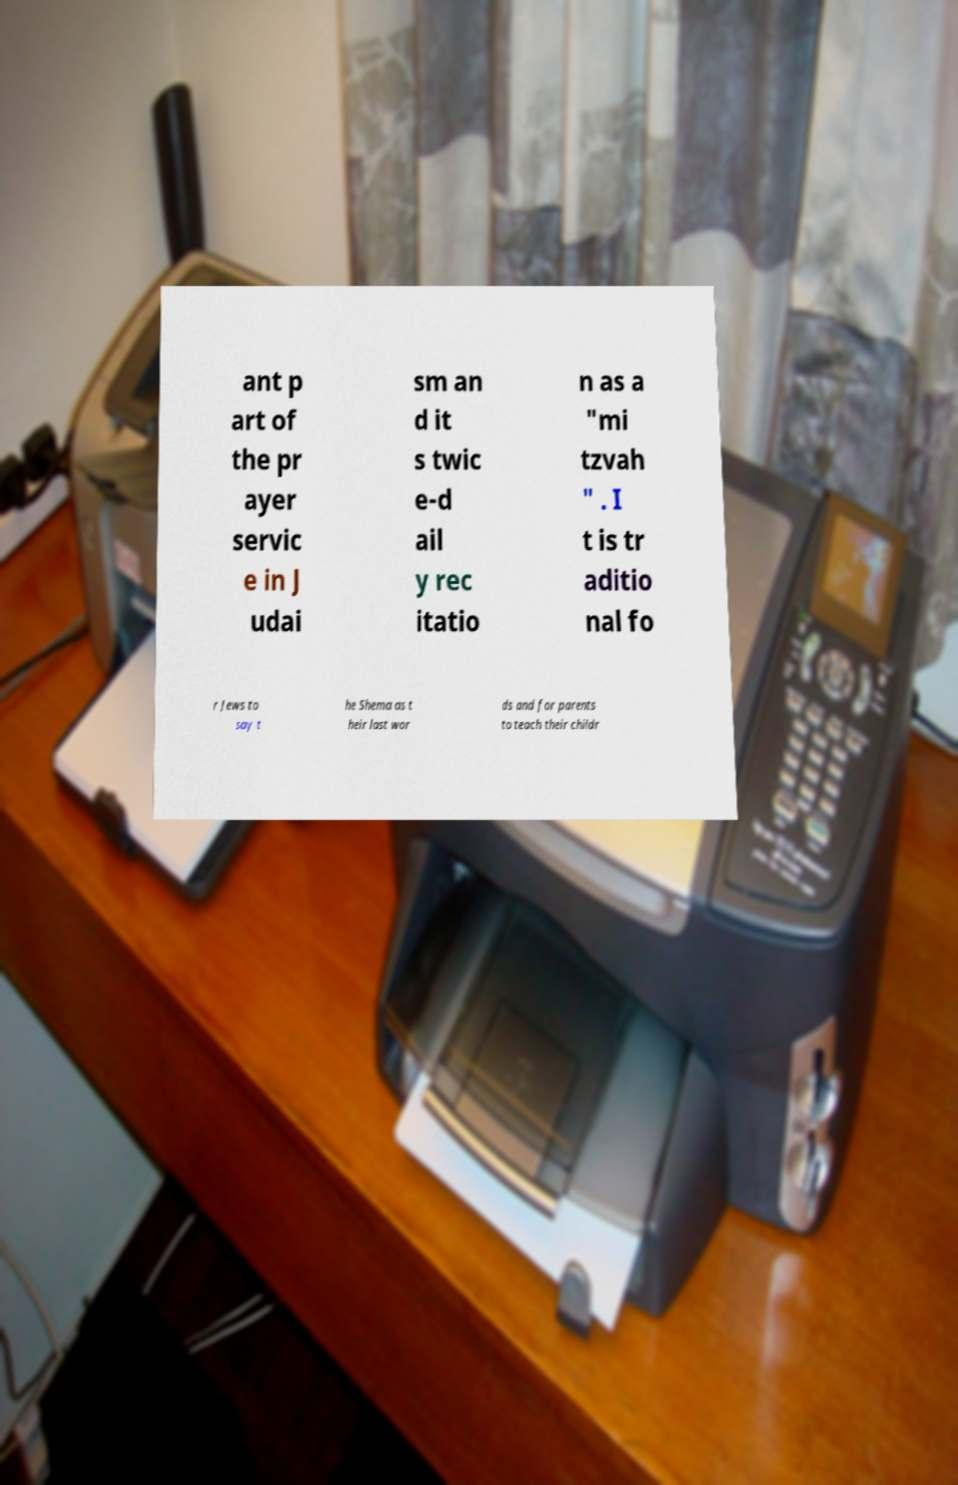Please read and relay the text visible in this image. What does it say? ant p art of the pr ayer servic e in J udai sm an d it s twic e-d ail y rec itatio n as a "mi tzvah " . I t is tr aditio nal fo r Jews to say t he Shema as t heir last wor ds and for parents to teach their childr 